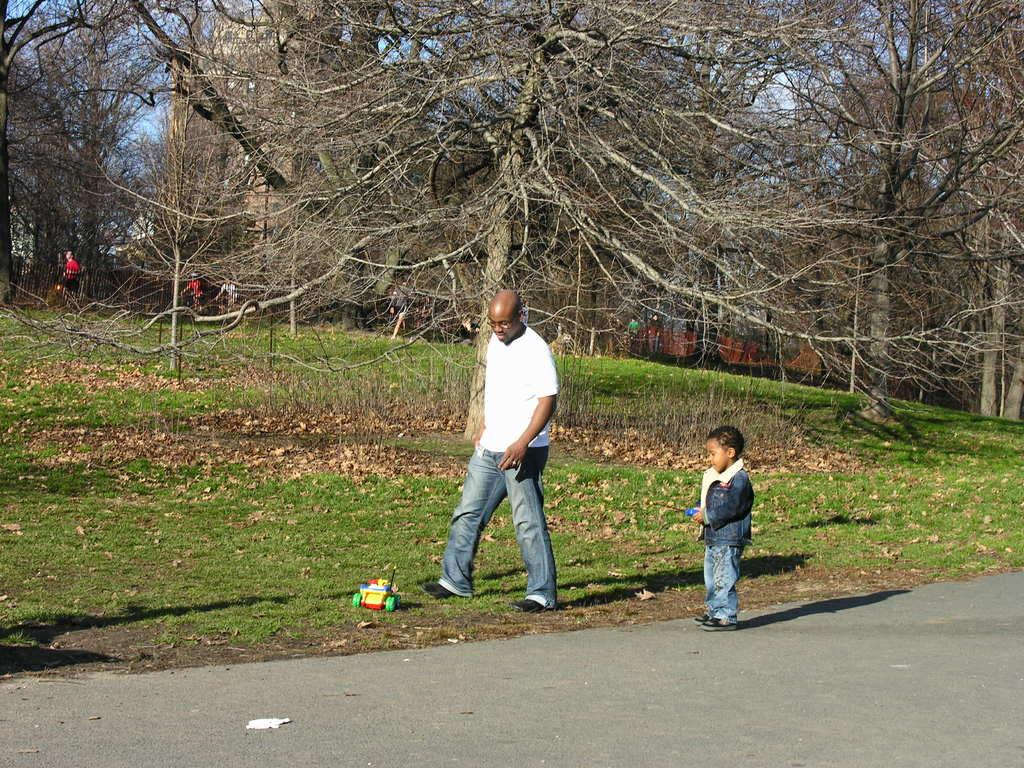Who is present in the image? There is a man and a boy in the image. What are the man and the boy doing in the image? Both the man and the boy are standing on the ground. What object can be seen in the image? There is a toy visible in the image. What type of terrain is present in the image? Grass is present in the image. What can be seen in the background of the image? Trees, a road, and the sky are visible in the background of the image. What type of leather is being used to create the caption in the image? There is no leather or caption present in the image; it is a photograph of a man and a boy standing on grass with a toy and a background of trees, road, and sky. 